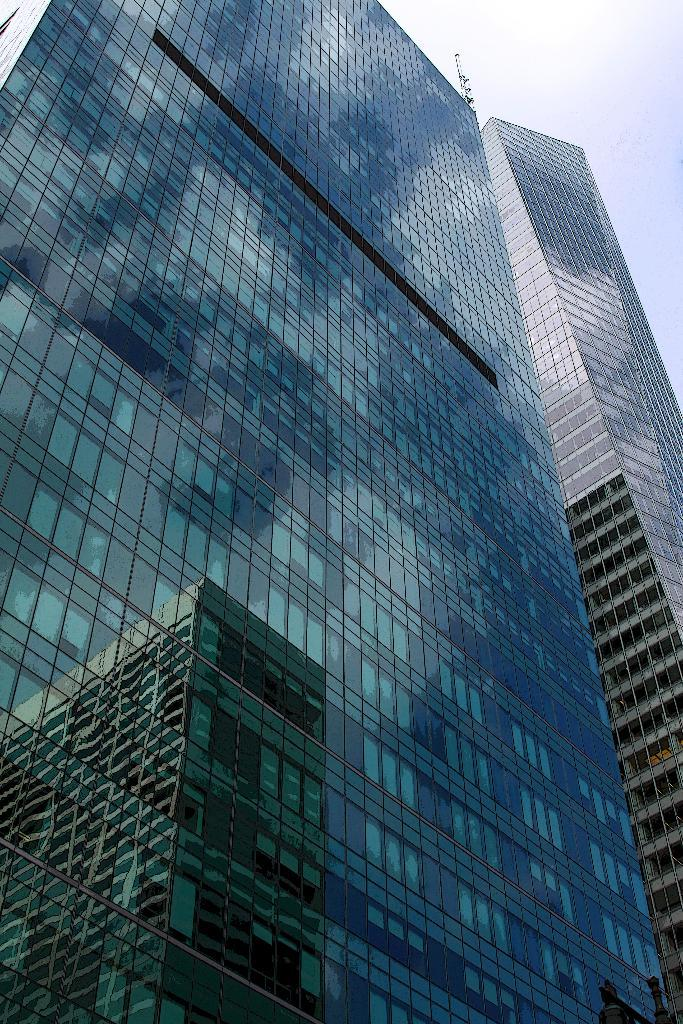What type of buildings are present in the image? There are buildings with glass in the image. Can you describe a unique feature of one of the buildings? One building has a reflection of another building. What can be seen in the background of the image? The sky is visible in the background of the image. How many basins are visible in the image? There are no basins present in the image. What type of range is visible in the image? There is no range present in the image. 